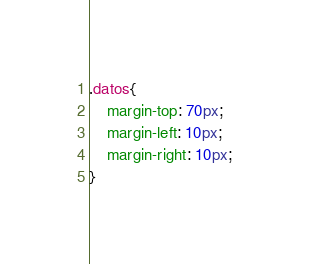<code> <loc_0><loc_0><loc_500><loc_500><_CSS_>.datos{
    margin-top: 70px;
    margin-left: 10px;
    margin-right: 10px;
}</code> 